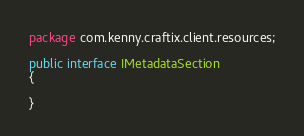Convert code to text. <code><loc_0><loc_0><loc_500><loc_500><_Java_>package com.kenny.craftix.client.resources;

public interface IMetadataSection 
{

}
</code> 